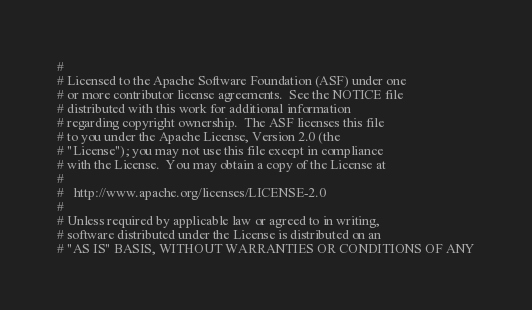<code> <loc_0><loc_0><loc_500><loc_500><_Python_>#
# Licensed to the Apache Software Foundation (ASF) under one
# or more contributor license agreements.  See the NOTICE file
# distributed with this work for additional information
# regarding copyright ownership.  The ASF licenses this file
# to you under the Apache License, Version 2.0 (the
# "License"); you may not use this file except in compliance
# with the License.  You may obtain a copy of the License at
#
#   http://www.apache.org/licenses/LICENSE-2.0
#
# Unless required by applicable law or agreed to in writing,
# software distributed under the License is distributed on an
# "AS IS" BASIS, WITHOUT WARRANTIES OR CONDITIONS OF ANY</code> 